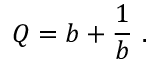Convert formula to latex. <formula><loc_0><loc_0><loc_500><loc_500>Q = b + { \frac { 1 } { b } } \ .</formula> 